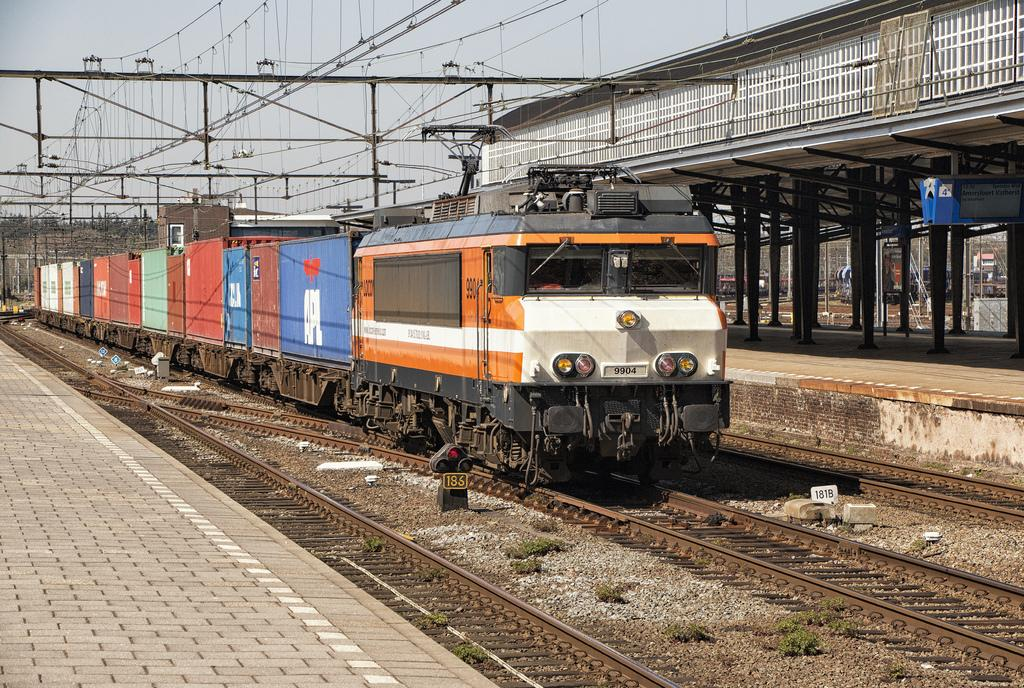What is the main subject of the image? The main subject of the image is a train. Where is the train located in the image? The train is on a train track in the image. What else can be seen in the image besides the train? There is a footpath, electric wires, electric poles, and the sky visible in the image. What type of prose is being recited by the train in the image? There is no indication in the image that the train is reciting any prose. What ornament is hanging from the electric poles in the image? There are no ornaments hanging from the electric poles in the image; only electric wires are visible. 